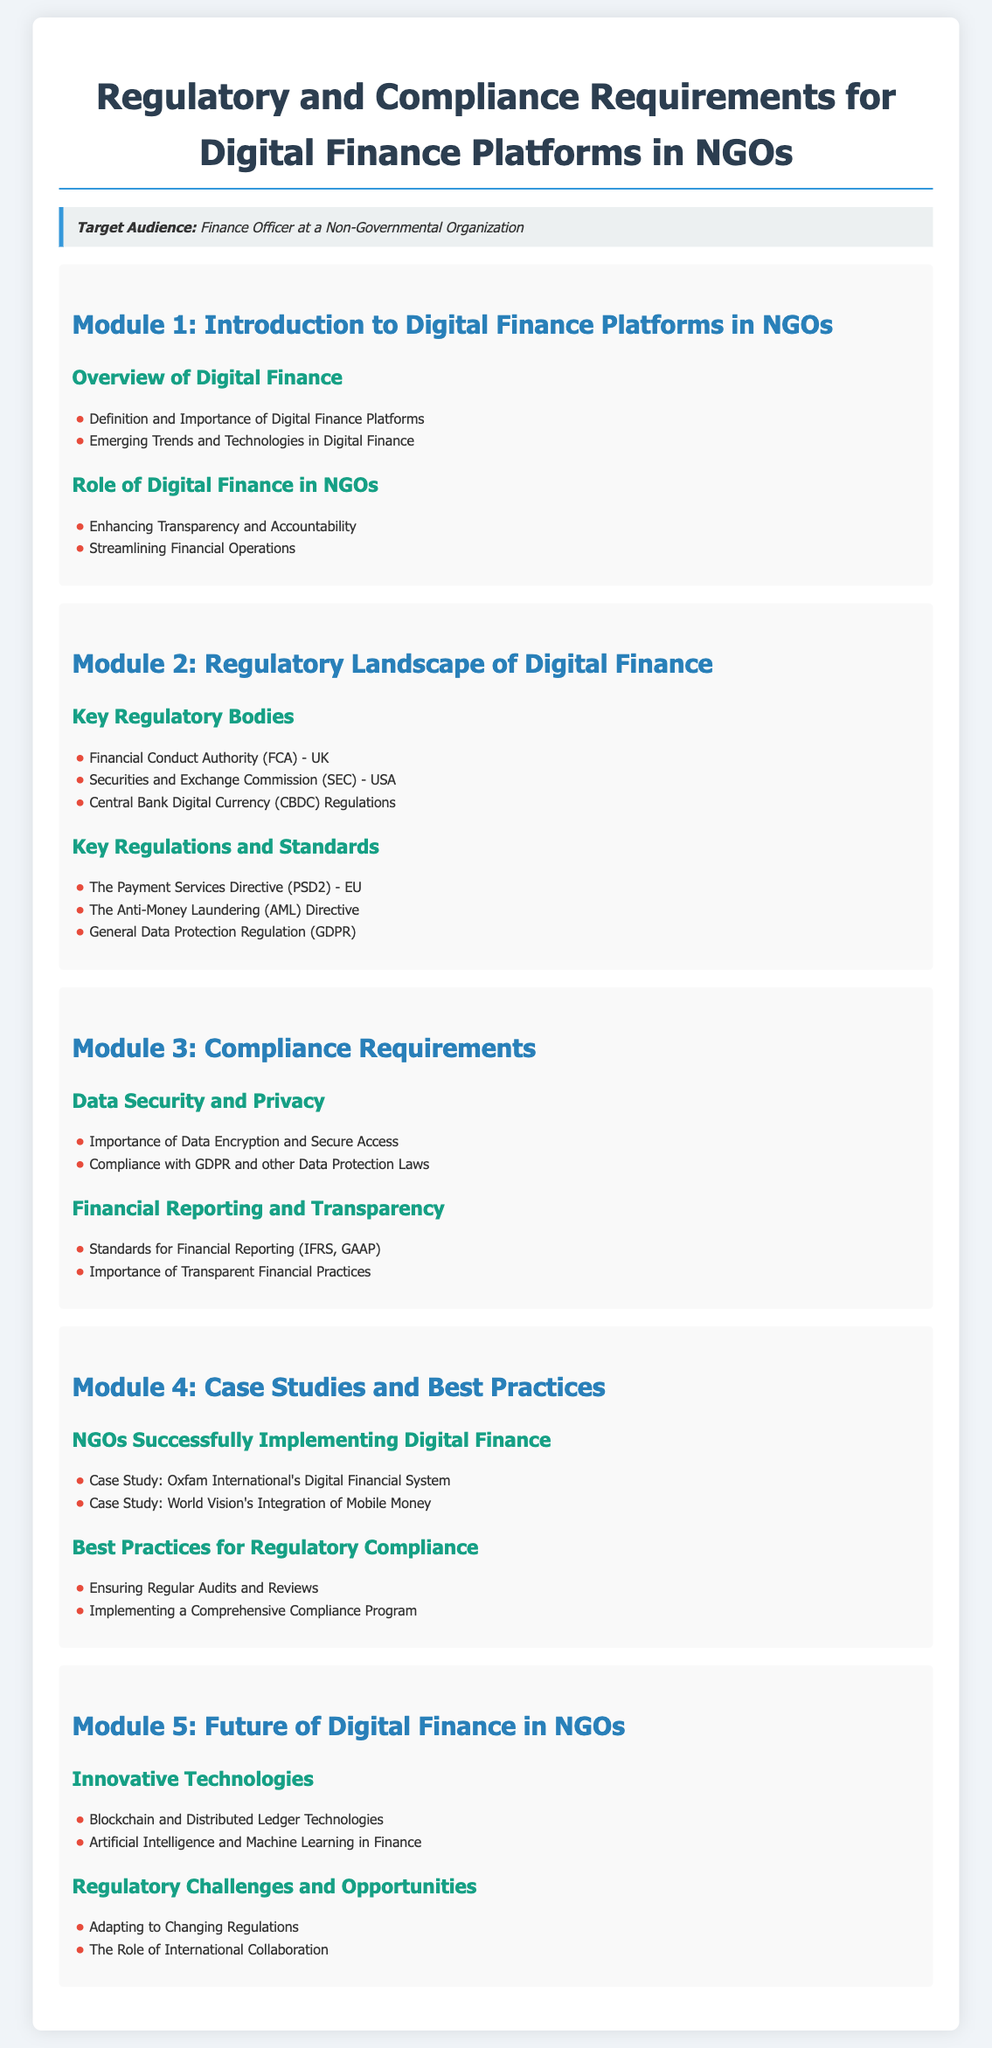What is the title of the syllabus? The title of the syllabus is found at the top of the document.
Answer: Regulatory and Compliance Requirements for Digital Finance Platforms in NGOs Who is the target audience? The target audience is specified in a dedicated section of the syllabus.
Answer: Finance Officer at a Non-Governmental Organization What are the key regulatory bodies mentioned? The document lists key regulatory bodies in Module 2.
Answer: Financial Conduct Authority (FCA) - UK, Securities and Exchange Commission (SEC) - USA, Central Bank Digital Currency (CBDC) Regulations What is an important regulation listed under Key Regulations and Standards? The syllabus includes various regulations under Module 2.
Answer: General Data Protection Regulation (GDPR) What is the focus of Module 3? The document states that Module 3 is dedicated to Compliance Requirements.
Answer: Compliance Requirements Name one case study mentioned in Module 4. The syllabus includes two case studies in Module 4 for successful digital finance implementation.
Answer: Oxfam International's Digital Financial System What is one type of innovative technology discussed in Module 5? The document provides insights into innovative technologies in the context of digital finance.
Answer: Blockchain and Distributed Ledger Technologies Which topic discusses financial reporting standards? The syllabus specifically addresses financial reporting in the context of compliance.
Answer: Financial Reporting and Transparency 